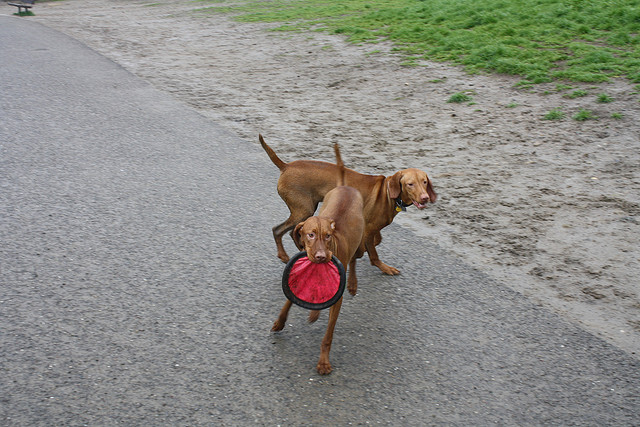<image>What plant is shown? I am not sure which plant is shown. It might be grass. What plant is shown? The plant shown is grass. 